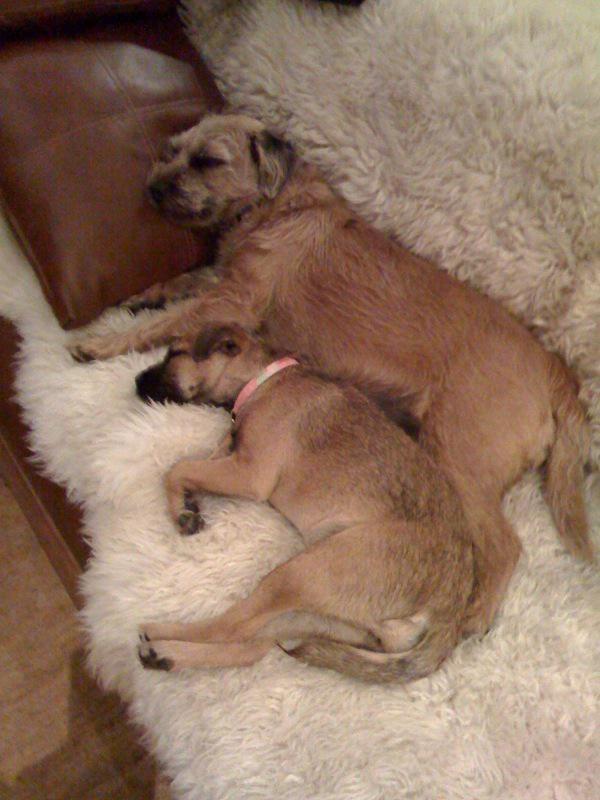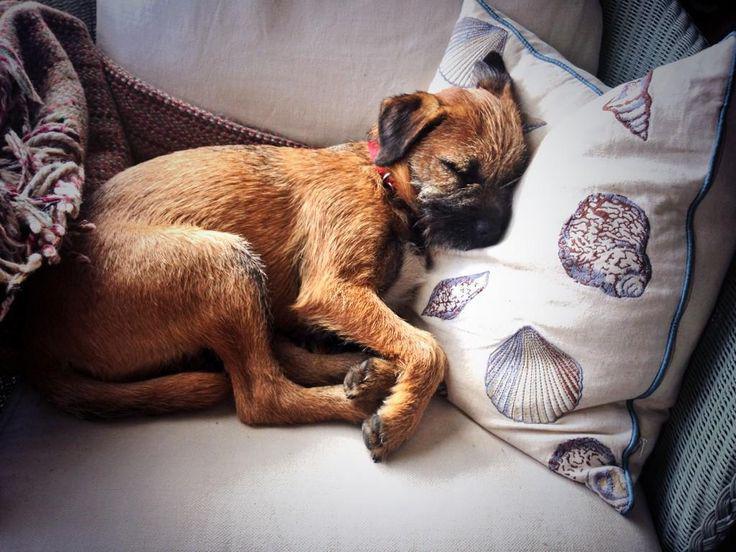The first image is the image on the left, the second image is the image on the right. Assess this claim about the two images: "At least one dog is sleeping on a throw pillow.". Correct or not? Answer yes or no. Yes. The first image is the image on the left, the second image is the image on the right. For the images shown, is this caption "One dog is sleeping on a piece of furniture with its head resting against a squarish patterned pillow." true? Answer yes or no. Yes. 